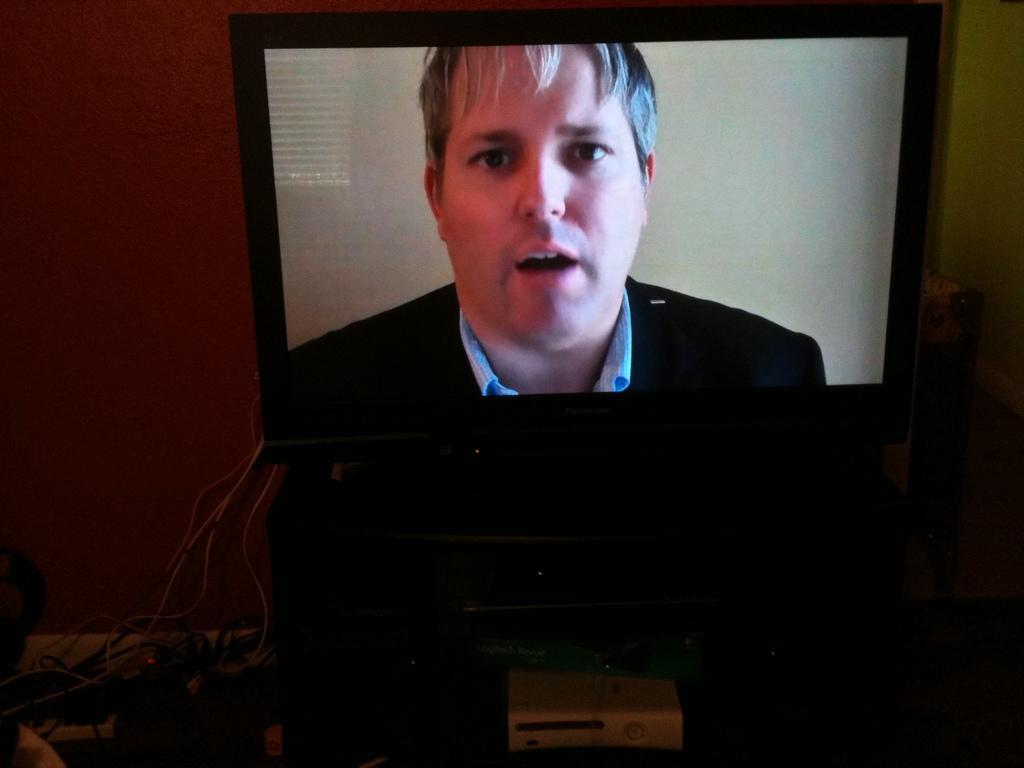Describe this image in one or two sentences. In the center of the image, we can see a tv and some cables are connected to it and we can see a man on the screen. 